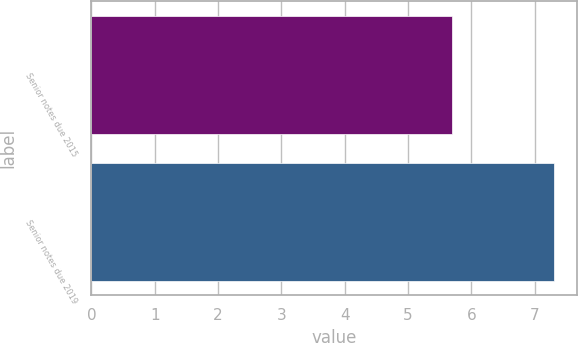Convert chart to OTSL. <chart><loc_0><loc_0><loc_500><loc_500><bar_chart><fcel>Senior notes due 2015<fcel>Senior notes due 2019<nl><fcel>5.7<fcel>7.3<nl></chart> 